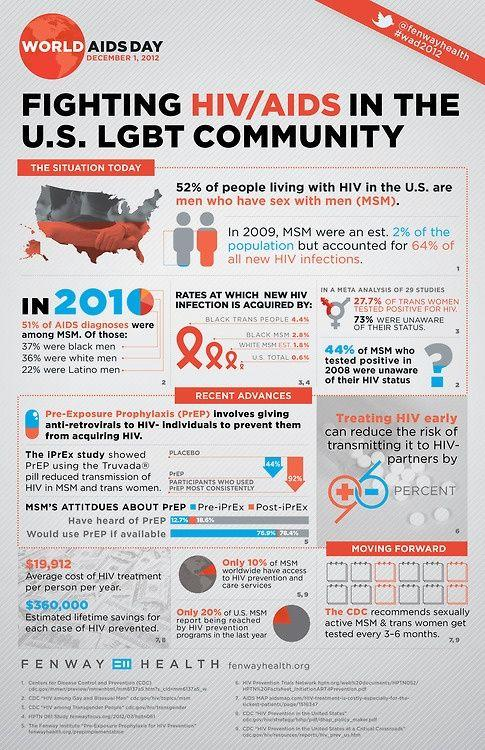Highlight a few significant elements in this photo. The average cost of HIV treatment per person per year is $19,912. Approximately 90% of men who have sex with men (MSM) do not have access to HIV prevention and care services. Early treatment of HIV can prevent transmission by up to 96%. The Centers for Disease Control and Prevention (CDC) recommend that tests be performed every 3-6 months. In 2020, the total percentage of white men and Latino men diagnosed with AIDS was 58%. 